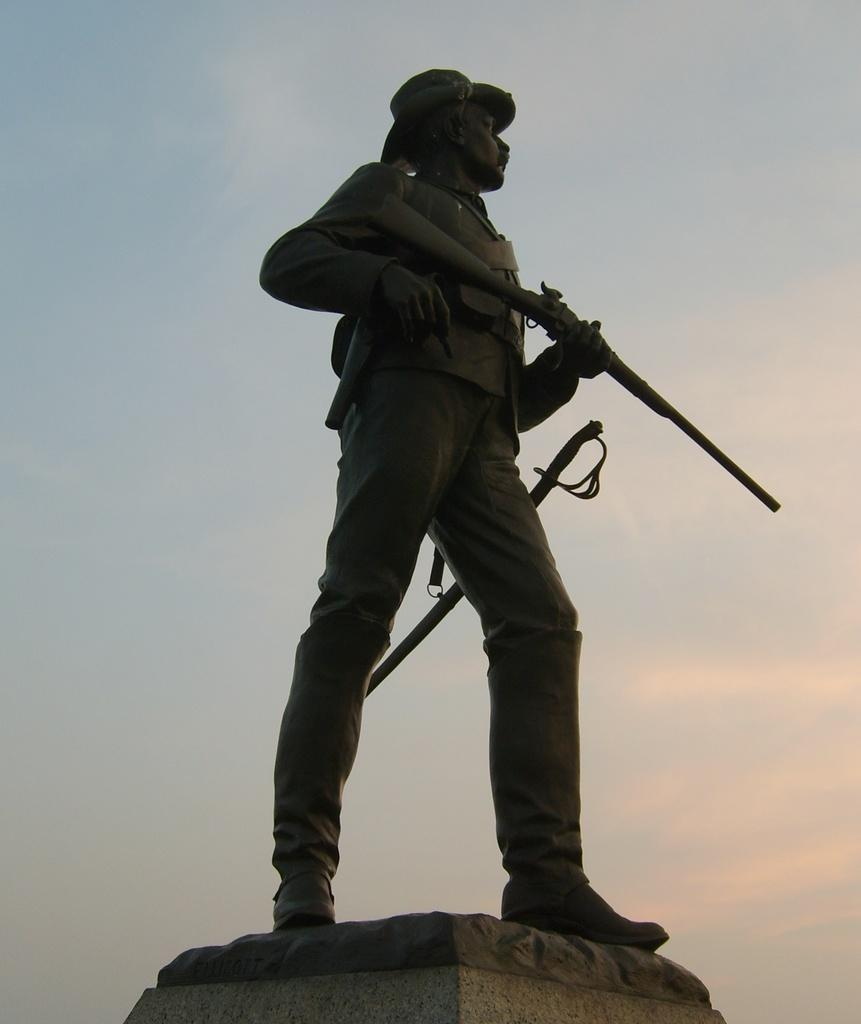What is the main subject of the image? There is a statue of a man in the image. What is the man depicted as wearing? The man is in uniform. What is the man's posture in the image? The man is standing. What object is the man holding in the image? The man is holding a rifle. What can be seen in the background of the image? The sky is visible in the background of the image. What type of metal is used to make the jam in the image? There is no jam present in the image, and therefore no metal can be associated with it. 